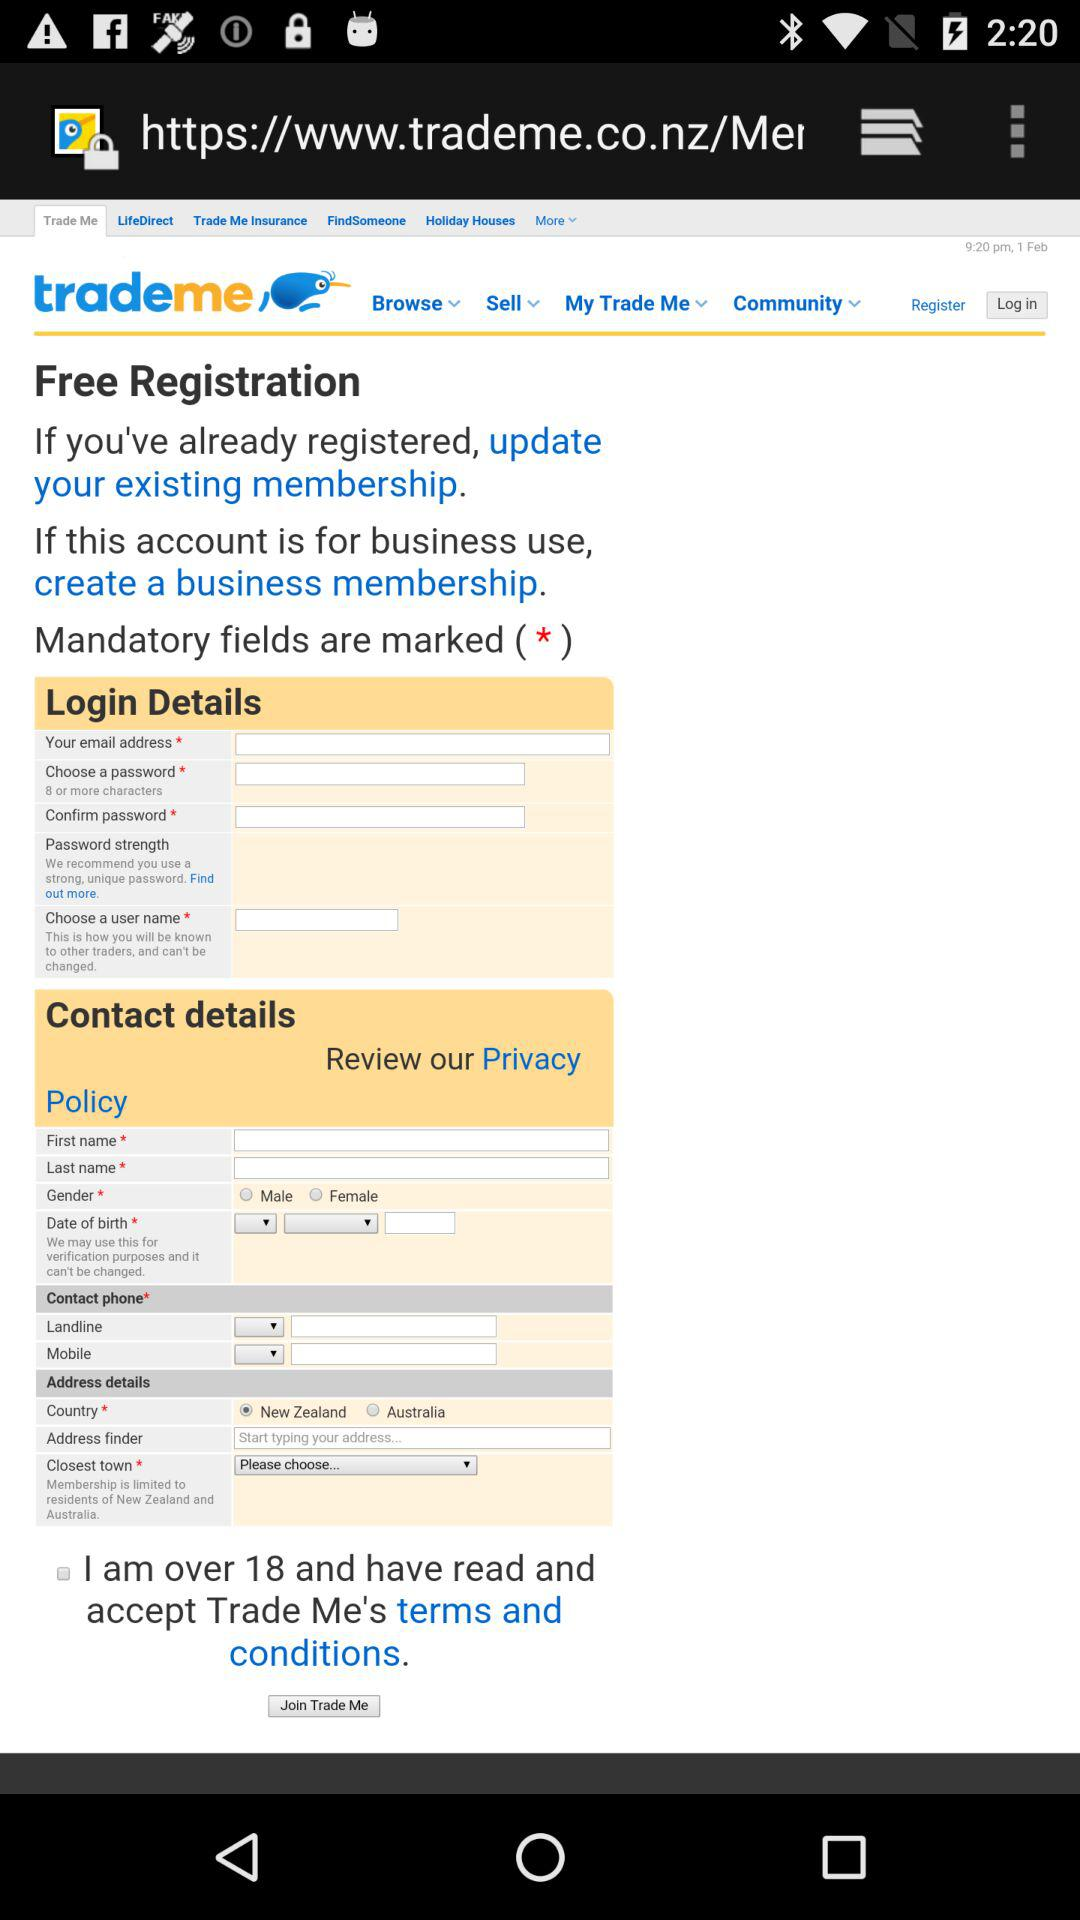What is the age limit to fill the form? The age limit to fill the form is over 18. 